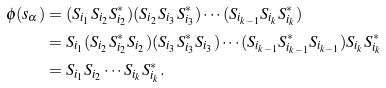<formula> <loc_0><loc_0><loc_500><loc_500>\phi ( s _ { \alpha } ) & = ( S _ { i _ { 1 } } S _ { i _ { 2 } } S _ { i _ { 2 } } ^ { * } ) ( S _ { i _ { 2 } } S _ { i _ { 3 } } S _ { i _ { 3 } } ^ { * } ) \cdots ( S _ { i _ { k - 1 } } S _ { i _ { k } } S _ { i _ { k } } ^ { * } ) \\ & = S _ { i _ { 1 } } ( S _ { i _ { 2 } } S _ { i _ { 2 } } ^ { * } S _ { i _ { 2 } } ) ( S _ { i _ { 3 } } S _ { i _ { 3 } } ^ { * } S _ { i _ { 3 } } ) \cdots ( S _ { i _ { k - 1 } } S _ { i _ { k - 1 } } ^ { * } S _ { i _ { k - 1 } } ) S _ { i _ { k } } S _ { i _ { k } } ^ { * } \\ & = S _ { i _ { 1 } } S _ { i _ { 2 } } \cdots S _ { i _ { k } } S _ { i _ { k } } ^ { * } .</formula> 